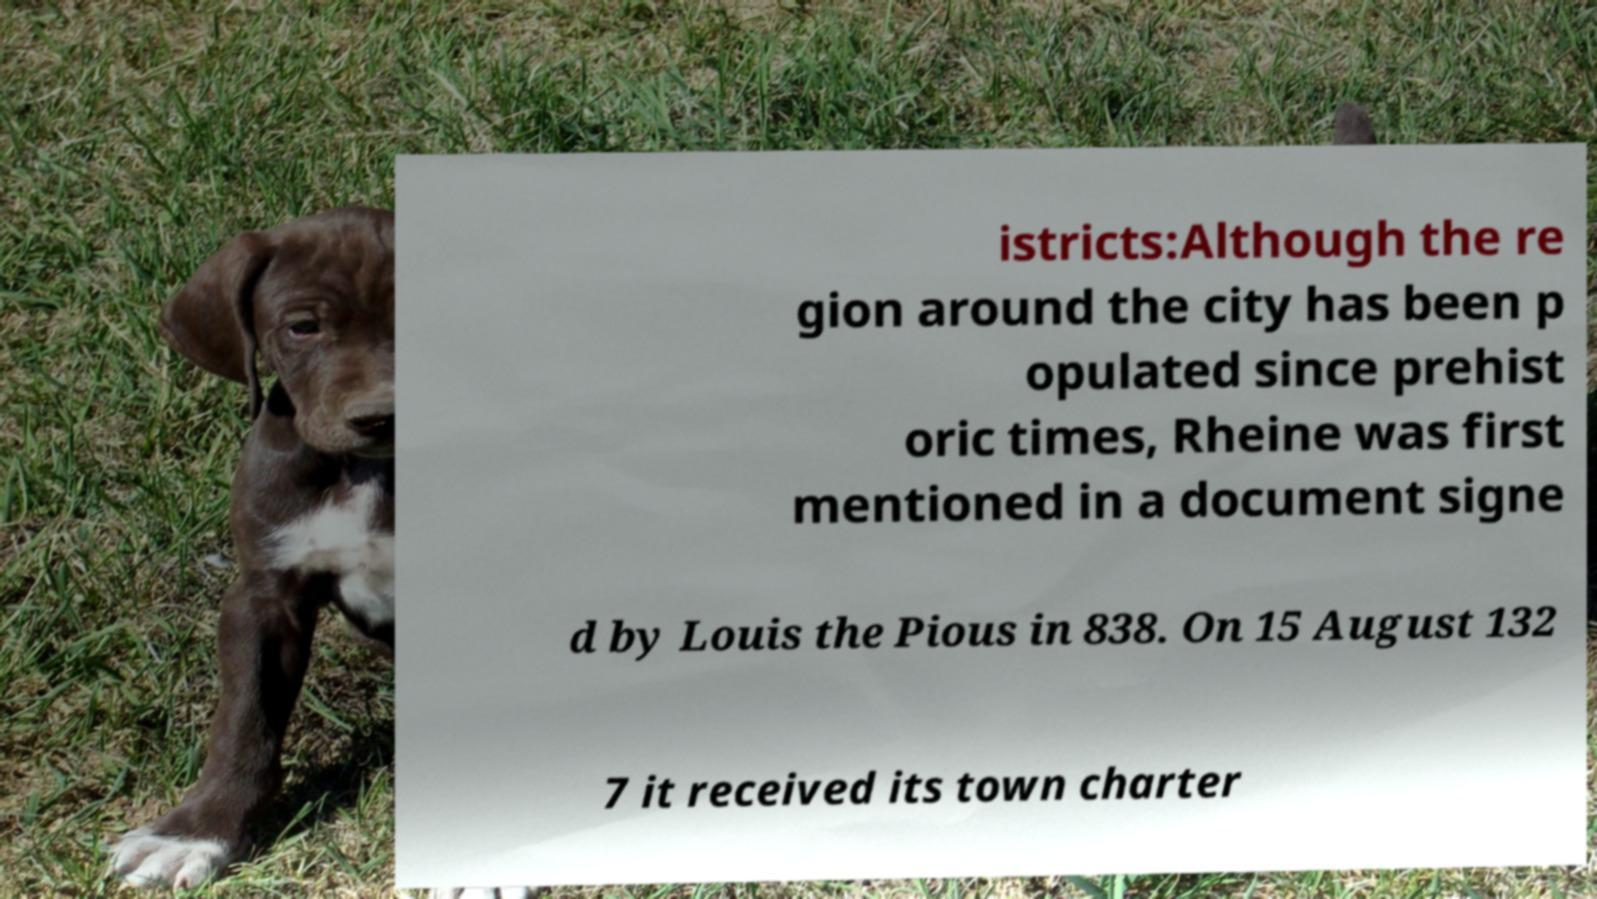Could you extract and type out the text from this image? istricts:Although the re gion around the city has been p opulated since prehist oric times, Rheine was first mentioned in a document signe d by Louis the Pious in 838. On 15 August 132 7 it received its town charter 